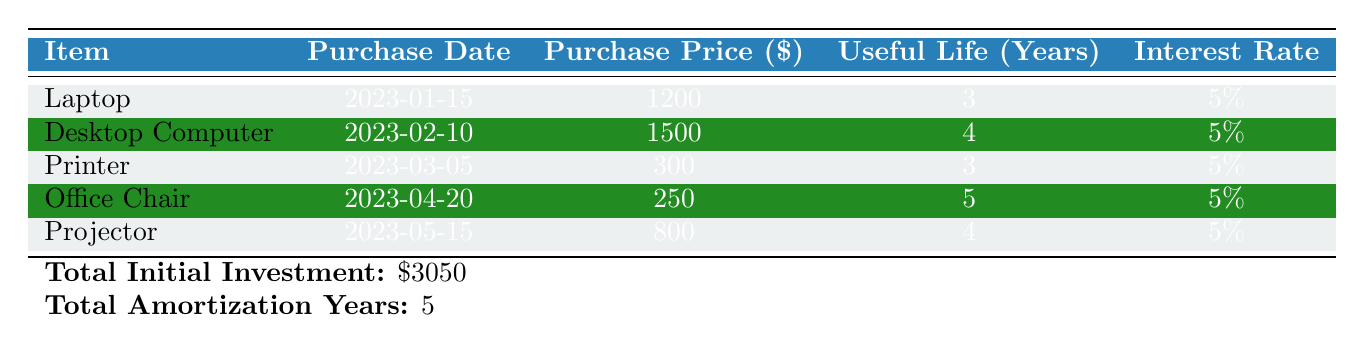What is the purchase price of the Laptop? The table lists the items and their corresponding purchase prices. The Laptop's purchase price is directly provided as \$1200.
Answer: 1200 How many years is the useful life of the Office Chair? The table specifies the useful life for each item. For the Office Chair, it is stated to be 5 years.
Answer: 5 What is the total initial investment for all equipment purchases? At the bottom of the table, the total initial investment is summarized. It shows that the total is \$3050.
Answer: 3050 Which item has the highest purchase price? By comparing the purchase prices listed in the table, the Desktop Computer at \$1500 has the highest price.
Answer: Desktop Computer Is the Printer useful for fewer years than the Laptop? The useful life of the Printer is 3 years, while that of the Laptop is also 3 years. Therefore, they are equal, leading to a "no" answer.
Answer: No What is the average purchase price of all equipment? To calculate the average, sum the purchase prices (\$1200 + \$1500 + \$300 + \$250 + \$800 = \$3050) and divide by the number of items (5). Therefore, the average is \$3050 / 5 = \$610.
Answer: 610 How many items have a useful life of more than 3 years? Checking the useful life of each item, the Desktop Computer, Office Chair, and Projector have useful lives of 4 or 5 years, summing up to 3 items.
Answer: 3 Is the interest rate for all items the same? The table indicates that all items share the same interest rate of 5%. Therefore, the answer is "yes."
Answer: Yes Which item was purchased most recently? The most recent purchase date listed is for the Projector on 2023-05-15. This identifies it as the most recently purchased item.
Answer: Projector 